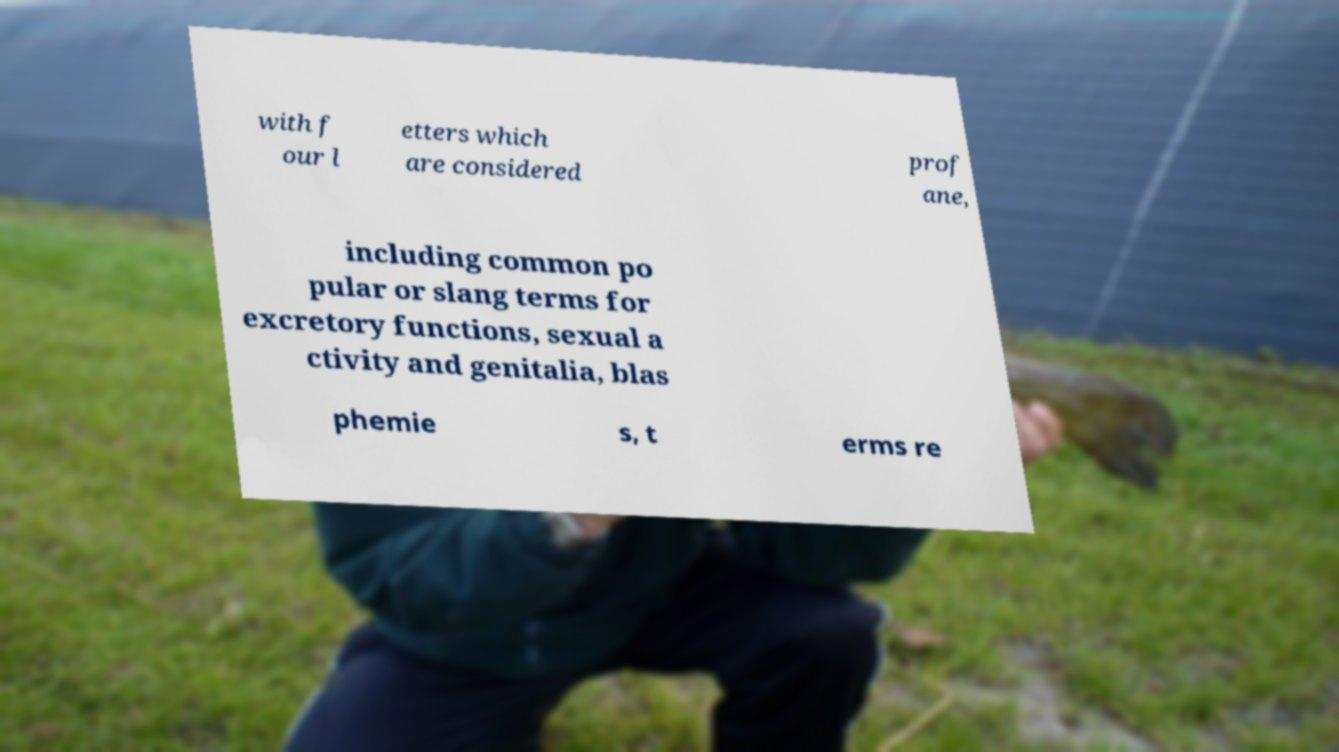Please read and relay the text visible in this image. What does it say? with f our l etters which are considered prof ane, including common po pular or slang terms for excretory functions, sexual a ctivity and genitalia, blas phemie s, t erms re 